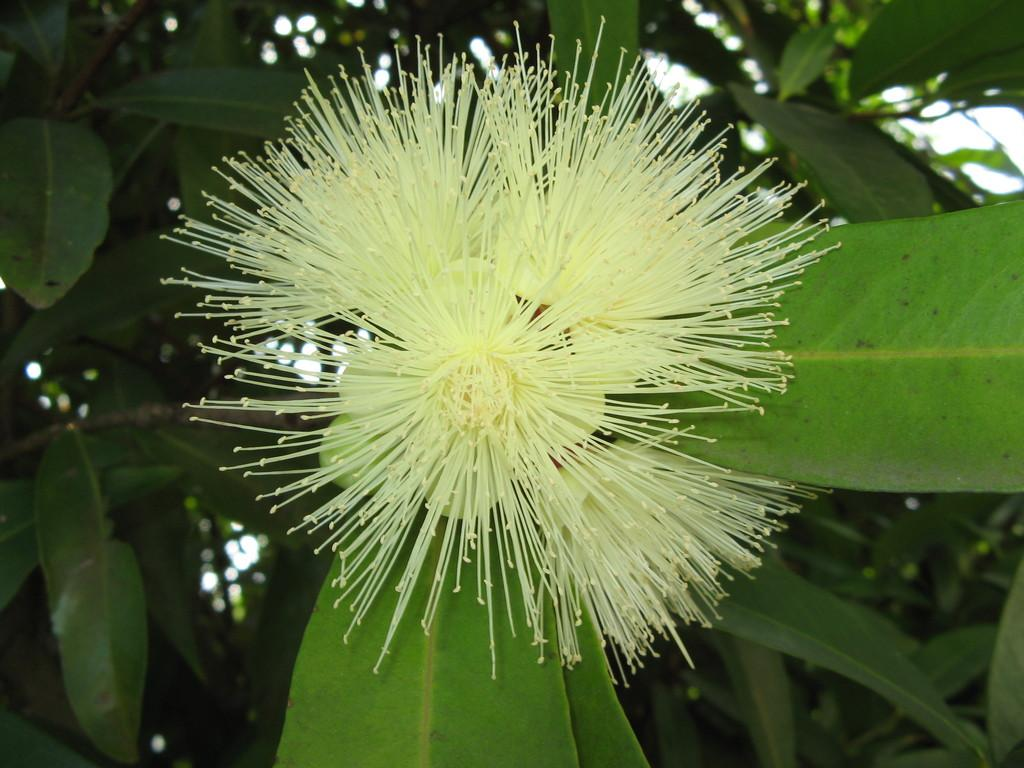What is present in the image? There is a plant in the image. What specific part of the plant is mentioned? The plant has a flower. What is the color of the flower? The flower is green in color. What else can be seen in the background of the image? There are leaves in the background of the image. Can you tell me how many ducks are swimming in the flower? There are no ducks present in the image, and the flower is green, not a body of water where ducks would swim. 